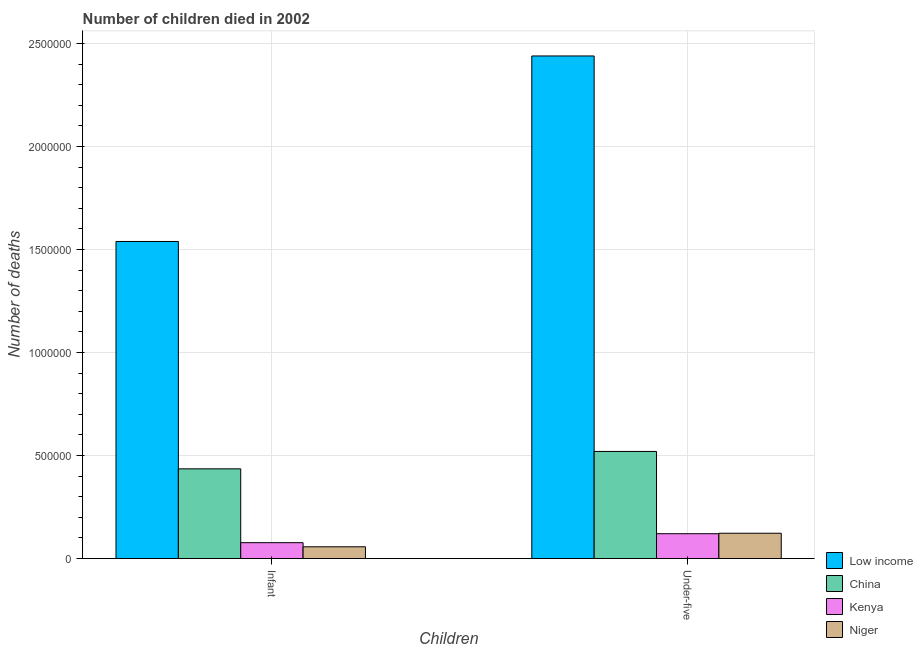Are the number of bars on each tick of the X-axis equal?
Offer a very short reply. Yes. How many bars are there on the 2nd tick from the left?
Offer a very short reply. 4. How many bars are there on the 1st tick from the right?
Ensure brevity in your answer.  4. What is the label of the 2nd group of bars from the left?
Keep it short and to the point. Under-five. What is the number of infant deaths in Kenya?
Your answer should be very brief. 7.71e+04. Across all countries, what is the maximum number of under-five deaths?
Make the answer very short. 2.44e+06. Across all countries, what is the minimum number of under-five deaths?
Provide a short and direct response. 1.21e+05. In which country was the number of infant deaths minimum?
Your answer should be very brief. Niger. What is the total number of under-five deaths in the graph?
Your answer should be compact. 3.20e+06. What is the difference between the number of under-five deaths in Low income and that in Kenya?
Keep it short and to the point. 2.32e+06. What is the difference between the number of infant deaths in Kenya and the number of under-five deaths in China?
Your answer should be very brief. -4.43e+05. What is the average number of infant deaths per country?
Provide a succinct answer. 5.27e+05. What is the difference between the number of under-five deaths and number of infant deaths in Kenya?
Your response must be concise. 4.35e+04. In how many countries, is the number of infant deaths greater than 1200000 ?
Your answer should be compact. 1. What is the ratio of the number of infant deaths in Low income to that in China?
Keep it short and to the point. 3.53. In how many countries, is the number of under-five deaths greater than the average number of under-five deaths taken over all countries?
Provide a short and direct response. 1. What does the 3rd bar from the left in Infant represents?
Provide a short and direct response. Kenya. What does the 3rd bar from the right in Infant represents?
Your answer should be compact. China. Are all the bars in the graph horizontal?
Make the answer very short. No. What is the difference between two consecutive major ticks on the Y-axis?
Your answer should be very brief. 5.00e+05. Are the values on the major ticks of Y-axis written in scientific E-notation?
Ensure brevity in your answer.  No. Does the graph contain grids?
Ensure brevity in your answer.  Yes. What is the title of the graph?
Provide a succinct answer. Number of children died in 2002. What is the label or title of the X-axis?
Offer a very short reply. Children. What is the label or title of the Y-axis?
Your answer should be very brief. Number of deaths. What is the Number of deaths of Low income in Infant?
Your response must be concise. 1.54e+06. What is the Number of deaths in China in Infant?
Keep it short and to the point. 4.36e+05. What is the Number of deaths of Kenya in Infant?
Provide a succinct answer. 7.71e+04. What is the Number of deaths in Niger in Infant?
Offer a very short reply. 5.71e+04. What is the Number of deaths in Low income in Under-five?
Offer a terse response. 2.44e+06. What is the Number of deaths of China in Under-five?
Provide a short and direct response. 5.20e+05. What is the Number of deaths of Kenya in Under-five?
Your answer should be compact. 1.21e+05. What is the Number of deaths in Niger in Under-five?
Ensure brevity in your answer.  1.23e+05. Across all Children, what is the maximum Number of deaths in Low income?
Offer a very short reply. 2.44e+06. Across all Children, what is the maximum Number of deaths in China?
Your response must be concise. 5.20e+05. Across all Children, what is the maximum Number of deaths of Kenya?
Offer a very short reply. 1.21e+05. Across all Children, what is the maximum Number of deaths in Niger?
Ensure brevity in your answer.  1.23e+05. Across all Children, what is the minimum Number of deaths of Low income?
Provide a succinct answer. 1.54e+06. Across all Children, what is the minimum Number of deaths in China?
Make the answer very short. 4.36e+05. Across all Children, what is the minimum Number of deaths of Kenya?
Your answer should be compact. 7.71e+04. Across all Children, what is the minimum Number of deaths of Niger?
Make the answer very short. 5.71e+04. What is the total Number of deaths in Low income in the graph?
Your answer should be compact. 3.98e+06. What is the total Number of deaths in China in the graph?
Keep it short and to the point. 9.55e+05. What is the total Number of deaths in Kenya in the graph?
Provide a succinct answer. 1.98e+05. What is the total Number of deaths of Niger in the graph?
Give a very brief answer. 1.80e+05. What is the difference between the Number of deaths of Low income in Infant and that in Under-five?
Give a very brief answer. -9.00e+05. What is the difference between the Number of deaths in China in Infant and that in Under-five?
Give a very brief answer. -8.44e+04. What is the difference between the Number of deaths of Kenya in Infant and that in Under-five?
Keep it short and to the point. -4.35e+04. What is the difference between the Number of deaths of Niger in Infant and that in Under-five?
Ensure brevity in your answer.  -6.58e+04. What is the difference between the Number of deaths in Low income in Infant and the Number of deaths in China in Under-five?
Keep it short and to the point. 1.02e+06. What is the difference between the Number of deaths in Low income in Infant and the Number of deaths in Kenya in Under-five?
Offer a very short reply. 1.42e+06. What is the difference between the Number of deaths of Low income in Infant and the Number of deaths of Niger in Under-five?
Ensure brevity in your answer.  1.42e+06. What is the difference between the Number of deaths in China in Infant and the Number of deaths in Kenya in Under-five?
Keep it short and to the point. 3.15e+05. What is the difference between the Number of deaths of China in Infant and the Number of deaths of Niger in Under-five?
Provide a short and direct response. 3.13e+05. What is the difference between the Number of deaths in Kenya in Infant and the Number of deaths in Niger in Under-five?
Keep it short and to the point. -4.58e+04. What is the average Number of deaths in Low income per Children?
Provide a short and direct response. 1.99e+06. What is the average Number of deaths of China per Children?
Your answer should be compact. 4.78e+05. What is the average Number of deaths of Kenya per Children?
Your response must be concise. 9.89e+04. What is the average Number of deaths in Niger per Children?
Your response must be concise. 9.00e+04. What is the difference between the Number of deaths in Low income and Number of deaths in China in Infant?
Offer a terse response. 1.10e+06. What is the difference between the Number of deaths of Low income and Number of deaths of Kenya in Infant?
Ensure brevity in your answer.  1.46e+06. What is the difference between the Number of deaths in Low income and Number of deaths in Niger in Infant?
Your answer should be compact. 1.48e+06. What is the difference between the Number of deaths of China and Number of deaths of Kenya in Infant?
Provide a succinct answer. 3.58e+05. What is the difference between the Number of deaths of China and Number of deaths of Niger in Infant?
Keep it short and to the point. 3.78e+05. What is the difference between the Number of deaths of Kenya and Number of deaths of Niger in Infant?
Offer a terse response. 2.00e+04. What is the difference between the Number of deaths in Low income and Number of deaths in China in Under-five?
Your response must be concise. 1.92e+06. What is the difference between the Number of deaths of Low income and Number of deaths of Kenya in Under-five?
Provide a short and direct response. 2.32e+06. What is the difference between the Number of deaths of Low income and Number of deaths of Niger in Under-five?
Provide a short and direct response. 2.32e+06. What is the difference between the Number of deaths in China and Number of deaths in Kenya in Under-five?
Your answer should be compact. 3.99e+05. What is the difference between the Number of deaths of China and Number of deaths of Niger in Under-five?
Your response must be concise. 3.97e+05. What is the difference between the Number of deaths of Kenya and Number of deaths of Niger in Under-five?
Give a very brief answer. -2225. What is the ratio of the Number of deaths in Low income in Infant to that in Under-five?
Provide a succinct answer. 0.63. What is the ratio of the Number of deaths in China in Infant to that in Under-five?
Provide a succinct answer. 0.84. What is the ratio of the Number of deaths in Kenya in Infant to that in Under-five?
Keep it short and to the point. 0.64. What is the ratio of the Number of deaths in Niger in Infant to that in Under-five?
Provide a succinct answer. 0.46. What is the difference between the highest and the second highest Number of deaths in Low income?
Your answer should be very brief. 9.00e+05. What is the difference between the highest and the second highest Number of deaths of China?
Give a very brief answer. 8.44e+04. What is the difference between the highest and the second highest Number of deaths in Kenya?
Your response must be concise. 4.35e+04. What is the difference between the highest and the second highest Number of deaths in Niger?
Your answer should be very brief. 6.58e+04. What is the difference between the highest and the lowest Number of deaths in Low income?
Provide a short and direct response. 9.00e+05. What is the difference between the highest and the lowest Number of deaths in China?
Your answer should be compact. 8.44e+04. What is the difference between the highest and the lowest Number of deaths of Kenya?
Your answer should be compact. 4.35e+04. What is the difference between the highest and the lowest Number of deaths of Niger?
Offer a terse response. 6.58e+04. 